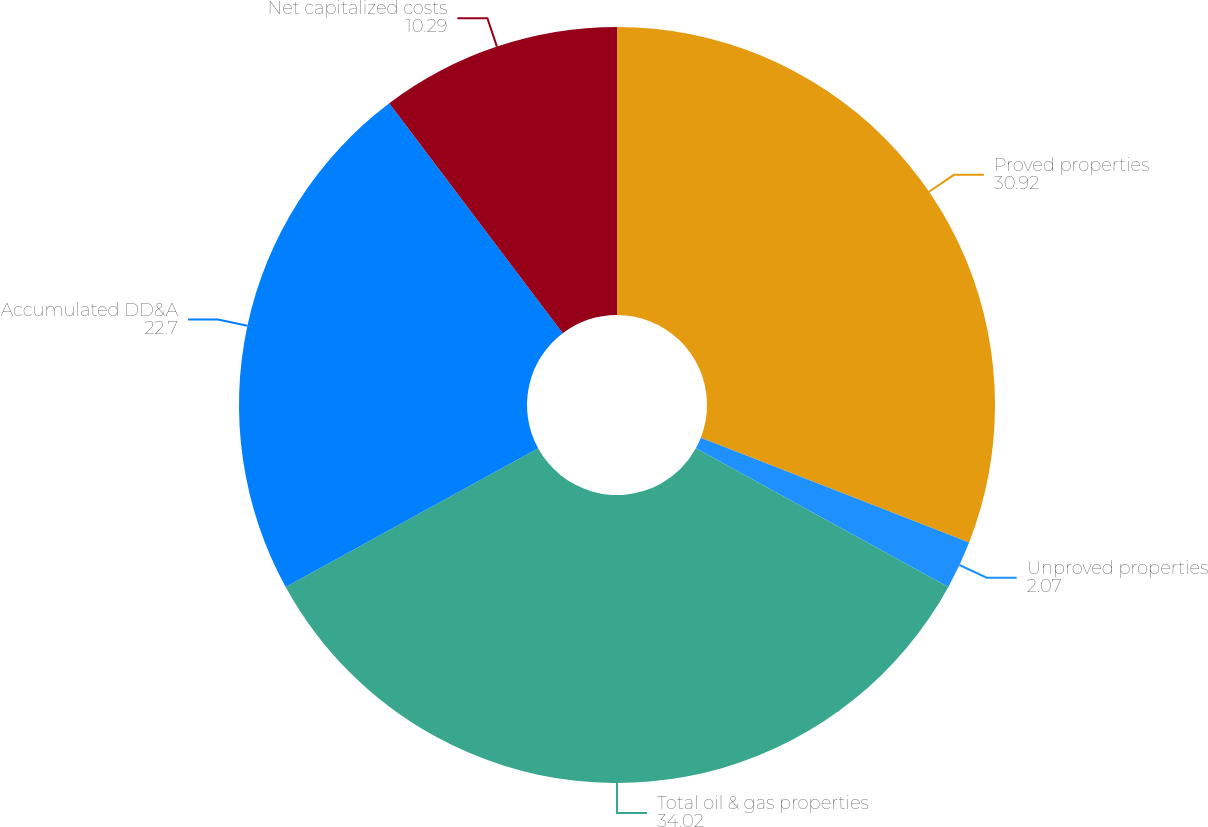<chart> <loc_0><loc_0><loc_500><loc_500><pie_chart><fcel>Proved properties<fcel>Unproved properties<fcel>Total oil & gas properties<fcel>Accumulated DD&A<fcel>Net capitalized costs<nl><fcel>30.92%<fcel>2.07%<fcel>34.02%<fcel>22.7%<fcel>10.29%<nl></chart> 